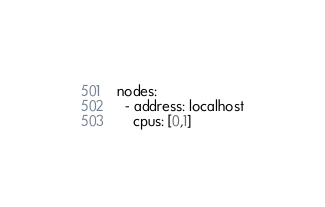<code> <loc_0><loc_0><loc_500><loc_500><_YAML_>nodes:
  - address: localhost
    cpus: [0,1]
</code> 